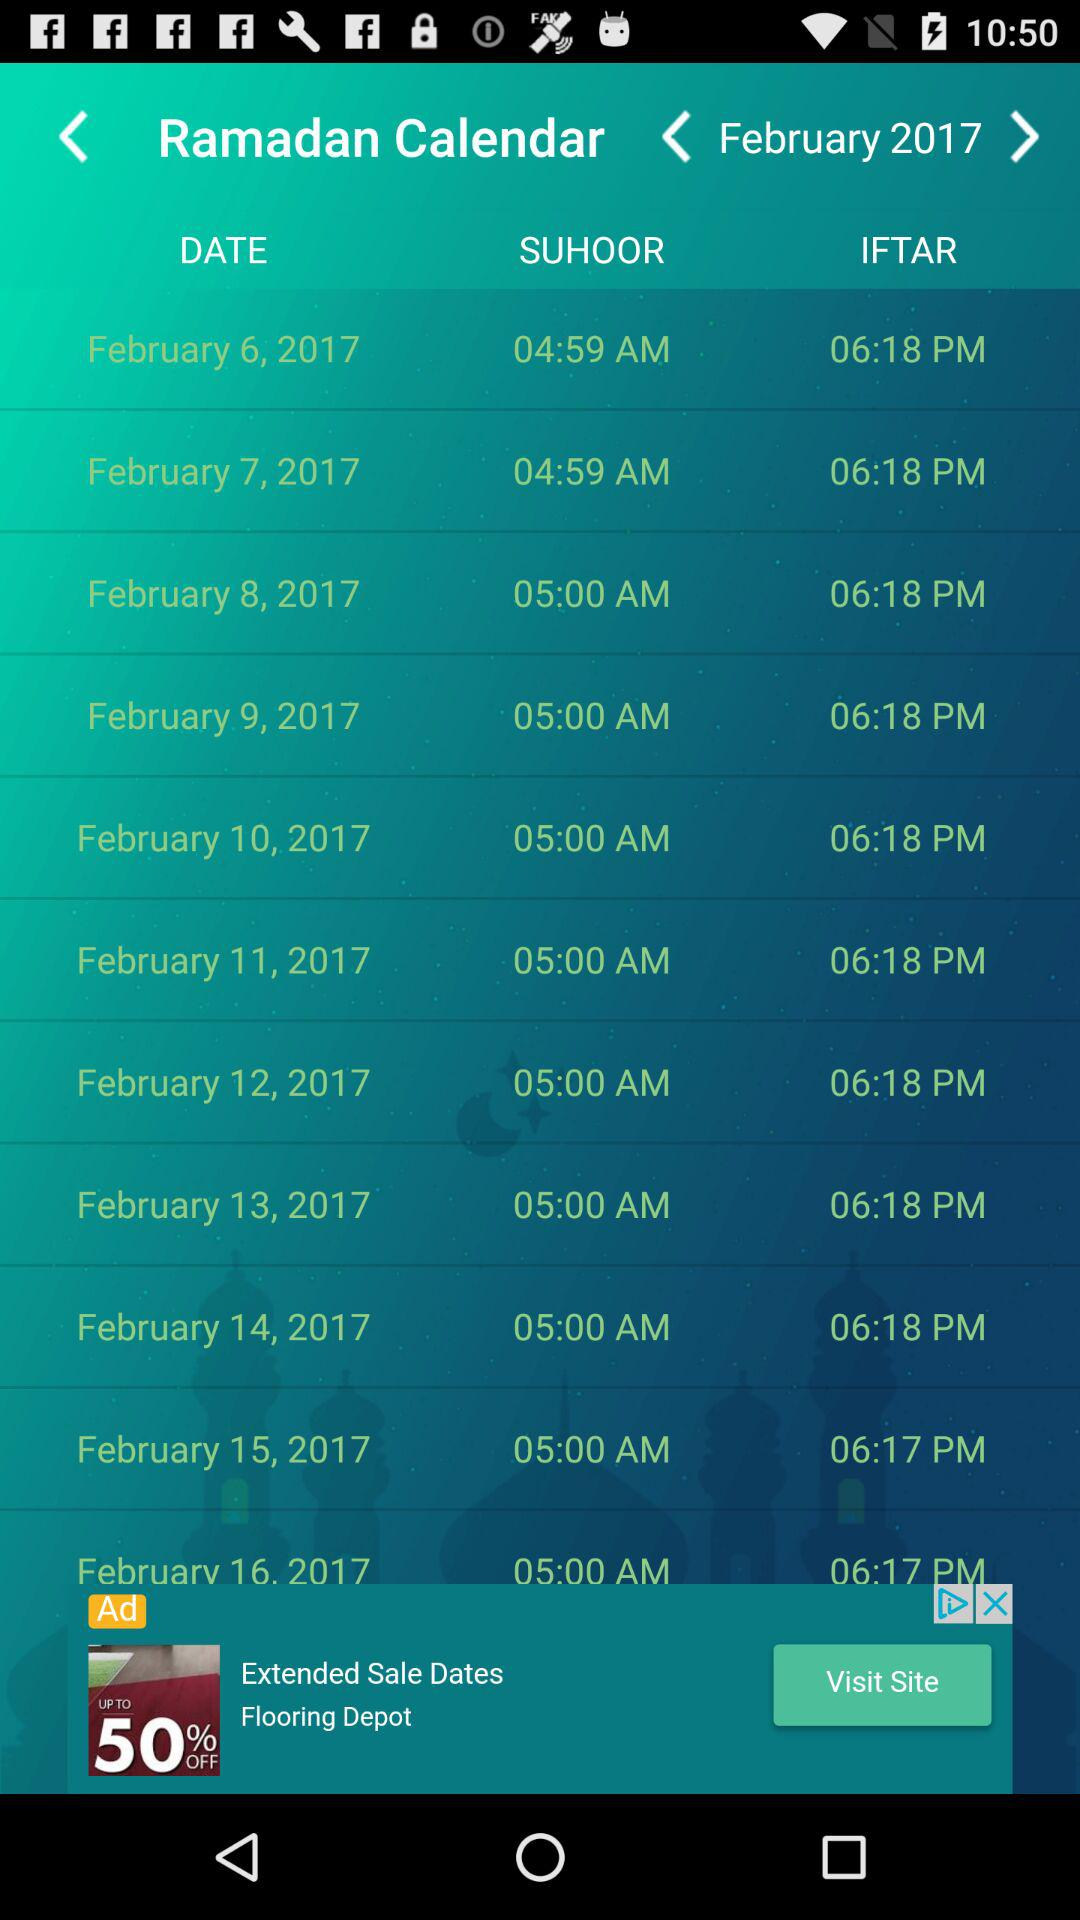What is the iftar time on 6th of February? The iftar time on 6th of February is 06:18 PM. 